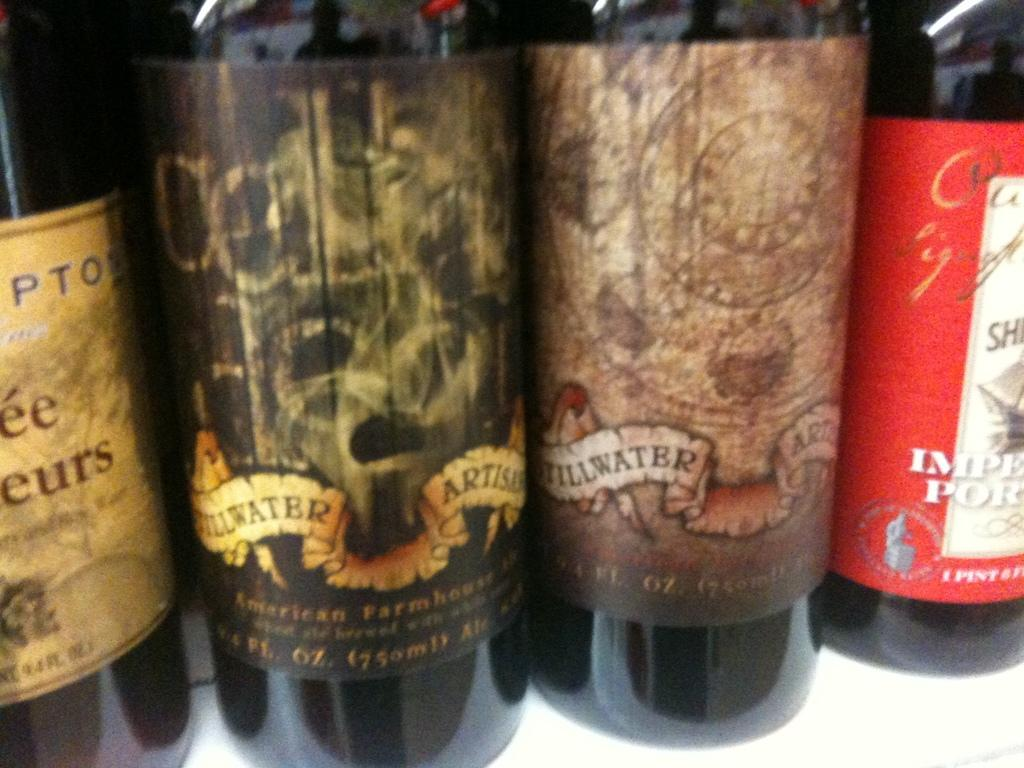<image>
Relay a brief, clear account of the picture shown. Some bottles of wine,  two of which have the words Stillwater visible. 